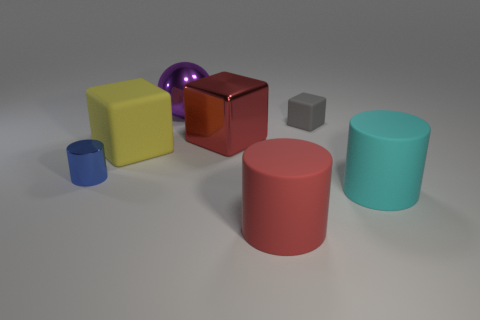What material is the cylinder on the right side of the red cylinder?
Your response must be concise. Rubber. Does the red rubber object have the same shape as the big matte object that is behind the small cylinder?
Give a very brief answer. No. Are there more tiny red rubber spheres than large rubber cubes?
Ensure brevity in your answer.  No. Is there any other thing of the same color as the small matte cube?
Give a very brief answer. No. There is a tiny gray thing that is made of the same material as the yellow block; what shape is it?
Offer a very short reply. Cube. The large red object that is behind the big matte thing to the right of the small gray rubber cube is made of what material?
Ensure brevity in your answer.  Metal. There is a big red object that is behind the blue shiny cylinder; does it have the same shape as the big yellow object?
Your answer should be compact. Yes. Is the number of purple balls behind the big yellow rubber thing greater than the number of large red cubes?
Keep it short and to the point. No. Are there any other things that have the same material as the big purple sphere?
Offer a very short reply. Yes. What is the shape of the big thing that is the same color as the metallic cube?
Keep it short and to the point. Cylinder. 